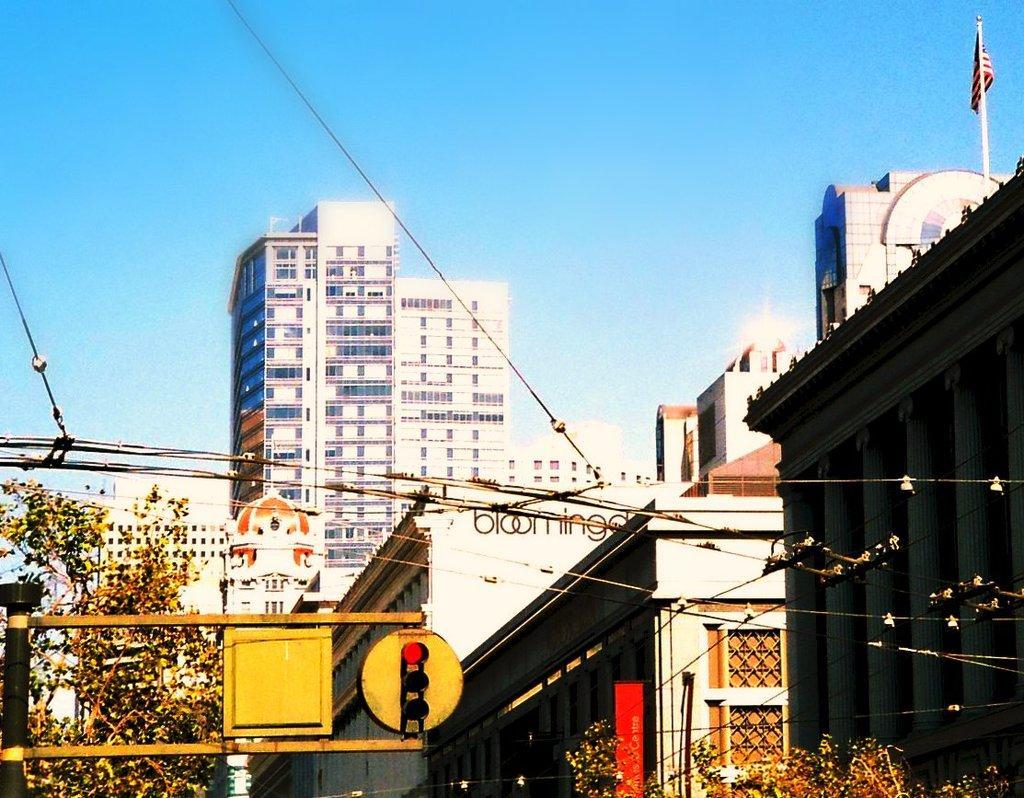In one or two sentences, can you explain what this image depicts? In this image there are trees, buildings, flags, electrical cables and traffic lights and there are banners on the buildings. 